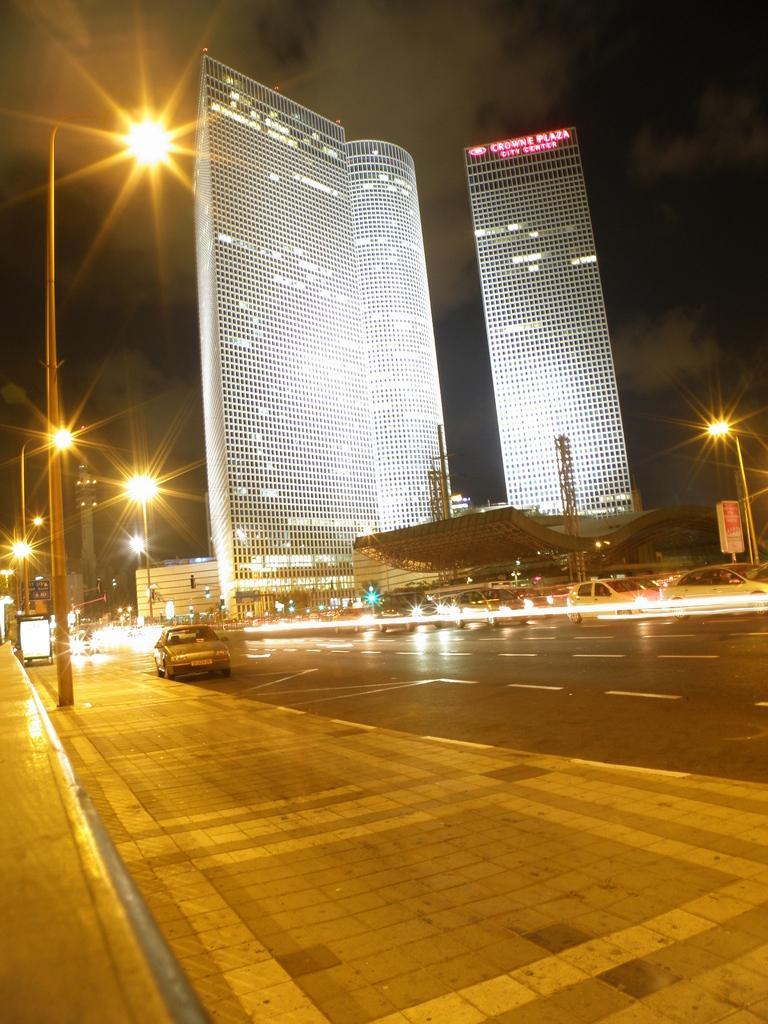In one or two sentences, can you explain what this image depicts? In this image I can see in the middle few vehicles are moving on the road, on the left side there are street lamps. In the middle there are very big buildings with lights, at the top it is the sky. 